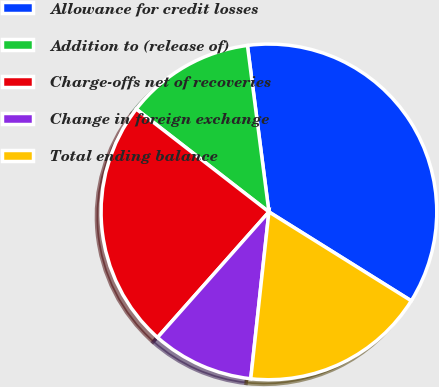<chart> <loc_0><loc_0><loc_500><loc_500><pie_chart><fcel>Allowance for credit losses<fcel>Addition to (release of)<fcel>Charge-offs net of recoveries<fcel>Change in foreign exchange<fcel>Total ending balance<nl><fcel>35.93%<fcel>12.46%<fcel>23.95%<fcel>9.82%<fcel>17.84%<nl></chart> 